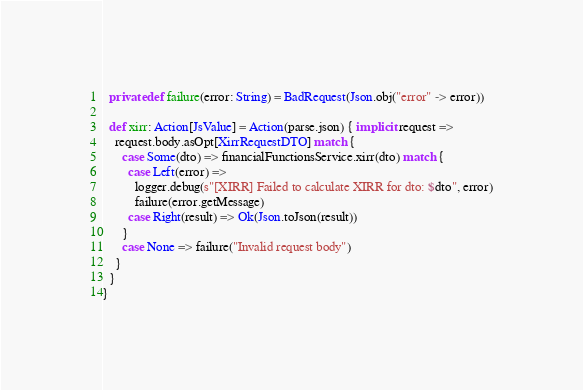<code> <loc_0><loc_0><loc_500><loc_500><_Scala_>
  private def failure(error: String) = BadRequest(Json.obj("error" -> error))

  def xirr: Action[JsValue] = Action(parse.json) { implicit request =>
    request.body.asOpt[XirrRequestDTO] match {
      case Some(dto) => financialFunctionsService.xirr(dto) match {
        case Left(error) =>
          logger.debug(s"[XIRR] Failed to calculate XIRR for dto: $dto", error)
          failure(error.getMessage)
        case Right(result) => Ok(Json.toJson(result))
      }
      case None => failure("Invalid request body")
    }
  }
}
</code> 